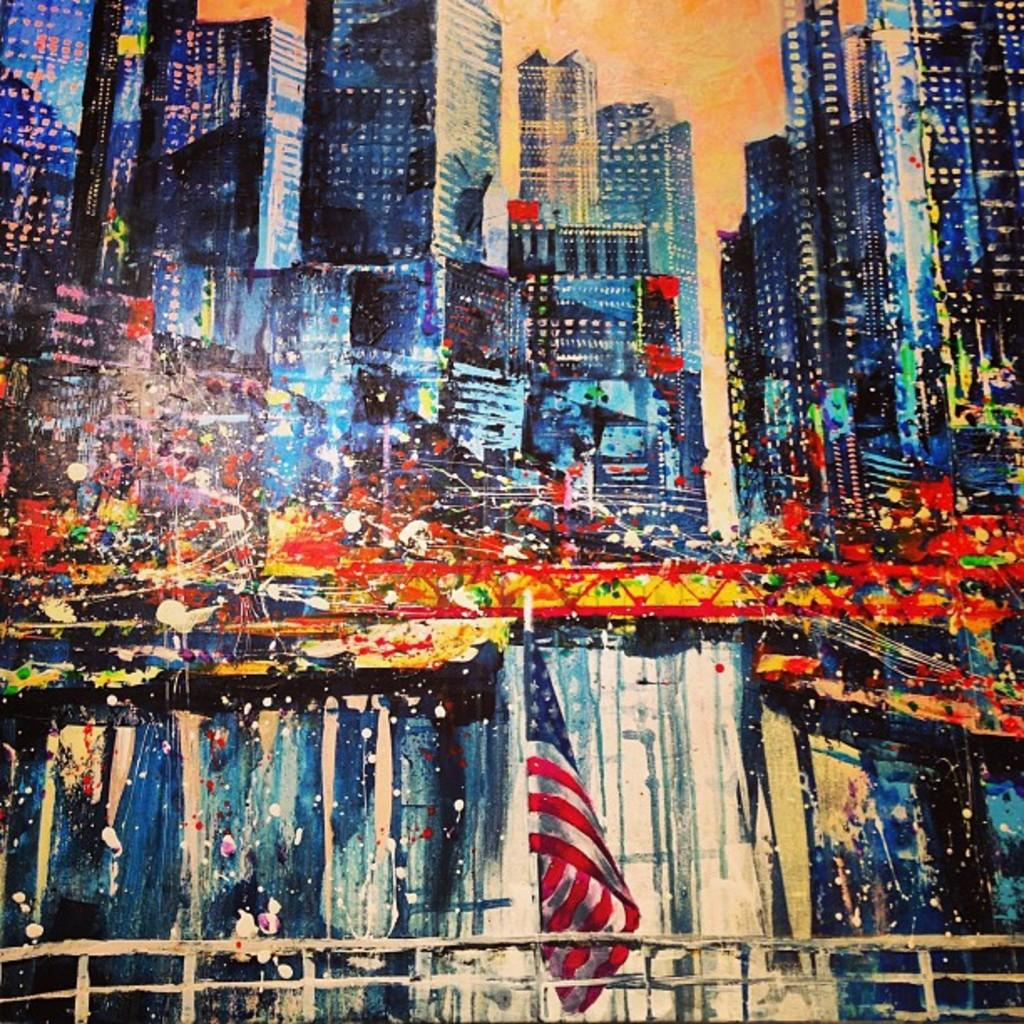What is the main subject of the image? There is a painting in the image. What else can be seen in the image besides the painting? There is a flag, a railing, a bridge, buildings, and the sky visible in the image. Can you describe the flag in the image? The flag is visible in the image, but its design or color is not mentioned in the provided facts. What type of structure is the bridge in the image? The type of bridge is not specified in the provided facts. What is visible in the background of the image? The sky is visible in the background of the image. How does the mind control the chain in the image? There is no mention of a mind or chain in the provided facts, so this question cannot be answered based on the information given. 